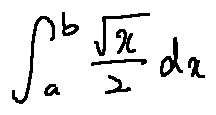<formula> <loc_0><loc_0><loc_500><loc_500>\int \lim i t s _ { a } ^ { b } \frac { \sqrt { x } } { 2 } d x</formula> 